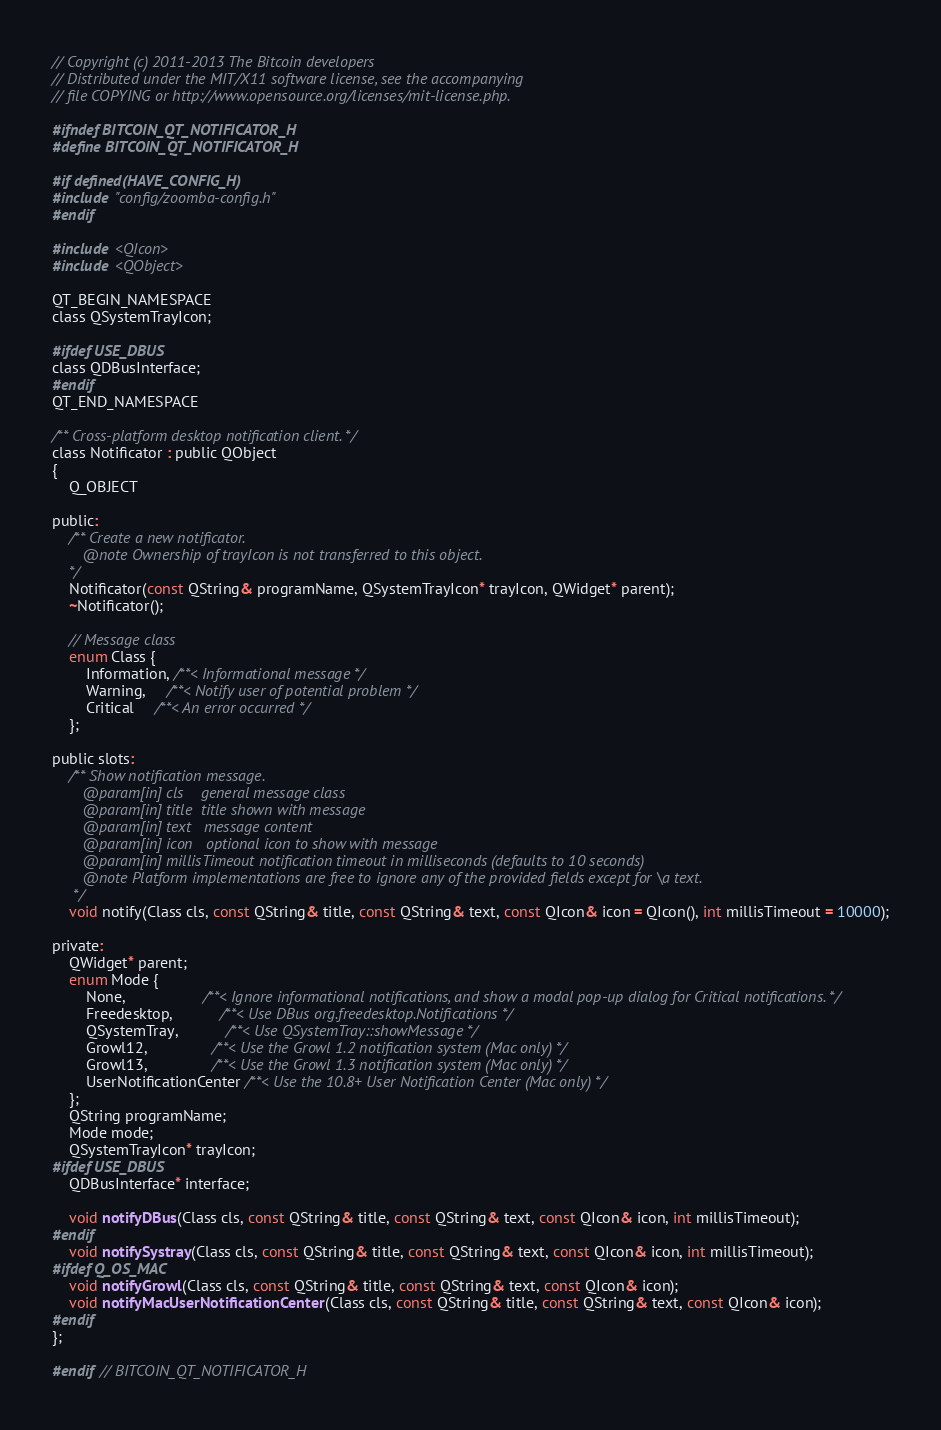Convert code to text. <code><loc_0><loc_0><loc_500><loc_500><_C_>// Copyright (c) 2011-2013 The Bitcoin developers
// Distributed under the MIT/X11 software license, see the accompanying
// file COPYING or http://www.opensource.org/licenses/mit-license.php.

#ifndef BITCOIN_QT_NOTIFICATOR_H
#define BITCOIN_QT_NOTIFICATOR_H

#if defined(HAVE_CONFIG_H)
#include "config/zoomba-config.h"
#endif

#include <QIcon>
#include <QObject>

QT_BEGIN_NAMESPACE
class QSystemTrayIcon;

#ifdef USE_DBUS
class QDBusInterface;
#endif
QT_END_NAMESPACE

/** Cross-platform desktop notification client. */
class Notificator : public QObject
{
    Q_OBJECT

public:
    /** Create a new notificator.
       @note Ownership of trayIcon is not transferred to this object.
    */
    Notificator(const QString& programName, QSystemTrayIcon* trayIcon, QWidget* parent);
    ~Notificator();

    // Message class
    enum Class {
        Information, /**< Informational message */
        Warning,     /**< Notify user of potential problem */
        Critical     /**< An error occurred */
    };

public slots:
    /** Show notification message.
       @param[in] cls    general message class
       @param[in] title  title shown with message
       @param[in] text   message content
       @param[in] icon   optional icon to show with message
       @param[in] millisTimeout notification timeout in milliseconds (defaults to 10 seconds)
       @note Platform implementations are free to ignore any of the provided fields except for \a text.
     */
    void notify(Class cls, const QString& title, const QString& text, const QIcon& icon = QIcon(), int millisTimeout = 10000);

private:
    QWidget* parent;
    enum Mode {
        None,                  /**< Ignore informational notifications, and show a modal pop-up dialog for Critical notifications. */
        Freedesktop,           /**< Use DBus org.freedesktop.Notifications */
        QSystemTray,           /**< Use QSystemTray::showMessage */
        Growl12,               /**< Use the Growl 1.2 notification system (Mac only) */
        Growl13,               /**< Use the Growl 1.3 notification system (Mac only) */
        UserNotificationCenter /**< Use the 10.8+ User Notification Center (Mac only) */
    };
    QString programName;
    Mode mode;
    QSystemTrayIcon* trayIcon;
#ifdef USE_DBUS
    QDBusInterface* interface;

    void notifyDBus(Class cls, const QString& title, const QString& text, const QIcon& icon, int millisTimeout);
#endif
    void notifySystray(Class cls, const QString& title, const QString& text, const QIcon& icon, int millisTimeout);
#ifdef Q_OS_MAC
    void notifyGrowl(Class cls, const QString& title, const QString& text, const QIcon& icon);
    void notifyMacUserNotificationCenter(Class cls, const QString& title, const QString& text, const QIcon& icon);
#endif
};

#endif // BITCOIN_QT_NOTIFICATOR_H
</code> 